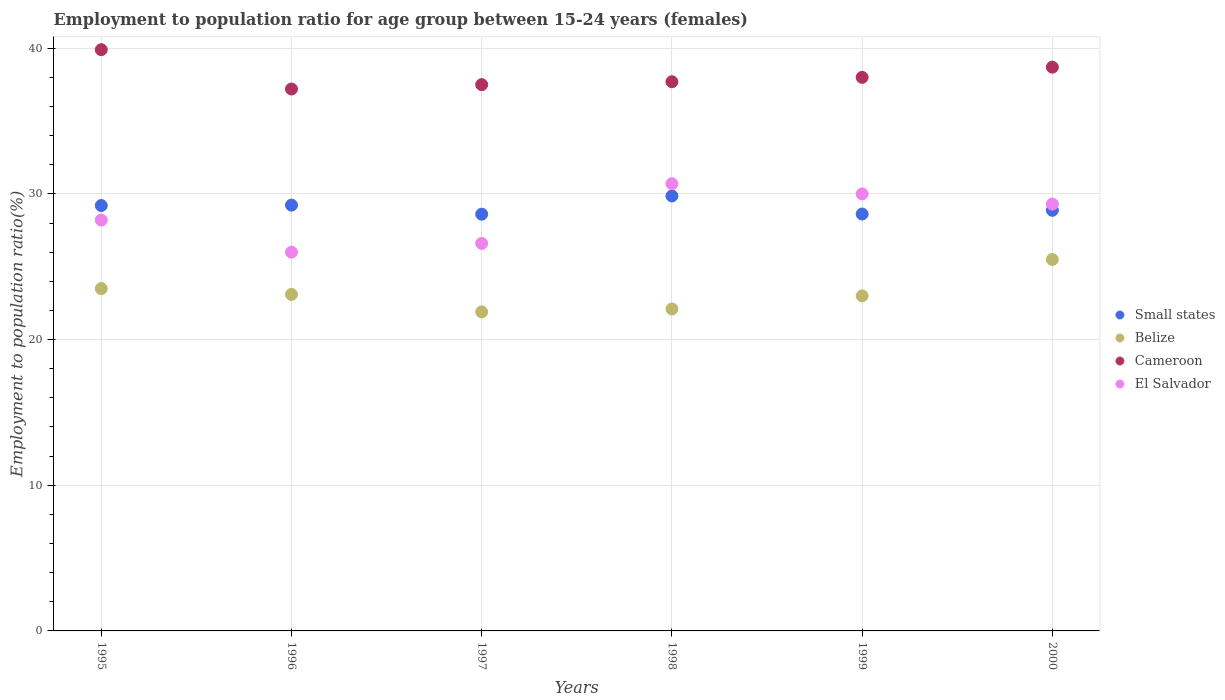Is the number of dotlines equal to the number of legend labels?
Keep it short and to the point. Yes. What is the employment to population ratio in Cameroon in 1997?
Your answer should be very brief. 37.5. Across all years, what is the maximum employment to population ratio in Small states?
Offer a very short reply. 29.86. Across all years, what is the minimum employment to population ratio in Cameroon?
Provide a succinct answer. 37.2. In which year was the employment to population ratio in Cameroon minimum?
Keep it short and to the point. 1996. What is the total employment to population ratio in El Salvador in the graph?
Your response must be concise. 170.8. What is the difference between the employment to population ratio in El Salvador in 1997 and that in 1998?
Your answer should be very brief. -4.1. What is the difference between the employment to population ratio in Cameroon in 1999 and the employment to population ratio in El Salvador in 2000?
Ensure brevity in your answer.  8.7. What is the average employment to population ratio in Cameroon per year?
Keep it short and to the point. 38.17. In the year 1998, what is the difference between the employment to population ratio in Belize and employment to population ratio in Small states?
Offer a very short reply. -7.76. In how many years, is the employment to population ratio in El Salvador greater than 2 %?
Your response must be concise. 6. What is the ratio of the employment to population ratio in Small states in 1998 to that in 1999?
Give a very brief answer. 1.04. What is the difference between the highest and the lowest employment to population ratio in Cameroon?
Ensure brevity in your answer.  2.7. Is it the case that in every year, the sum of the employment to population ratio in Cameroon and employment to population ratio in El Salvador  is greater than the employment to population ratio in Small states?
Offer a very short reply. Yes. Is the employment to population ratio in Cameroon strictly greater than the employment to population ratio in Small states over the years?
Your answer should be compact. Yes. What is the difference between two consecutive major ticks on the Y-axis?
Keep it short and to the point. 10. Does the graph contain any zero values?
Provide a succinct answer. No. Does the graph contain grids?
Offer a terse response. Yes. How many legend labels are there?
Make the answer very short. 4. What is the title of the graph?
Keep it short and to the point. Employment to population ratio for age group between 15-24 years (females). What is the label or title of the X-axis?
Offer a very short reply. Years. What is the label or title of the Y-axis?
Offer a terse response. Employment to population ratio(%). What is the Employment to population ratio(%) in Small states in 1995?
Your answer should be very brief. 29.2. What is the Employment to population ratio(%) in Cameroon in 1995?
Keep it short and to the point. 39.9. What is the Employment to population ratio(%) in El Salvador in 1995?
Ensure brevity in your answer.  28.2. What is the Employment to population ratio(%) in Small states in 1996?
Your answer should be compact. 29.23. What is the Employment to population ratio(%) in Belize in 1996?
Offer a terse response. 23.1. What is the Employment to population ratio(%) of Cameroon in 1996?
Give a very brief answer. 37.2. What is the Employment to population ratio(%) of El Salvador in 1996?
Give a very brief answer. 26. What is the Employment to population ratio(%) in Small states in 1997?
Your answer should be compact. 28.61. What is the Employment to population ratio(%) of Belize in 1997?
Offer a terse response. 21.9. What is the Employment to population ratio(%) of Cameroon in 1997?
Keep it short and to the point. 37.5. What is the Employment to population ratio(%) in El Salvador in 1997?
Your answer should be very brief. 26.6. What is the Employment to population ratio(%) of Small states in 1998?
Provide a succinct answer. 29.86. What is the Employment to population ratio(%) of Belize in 1998?
Offer a very short reply. 22.1. What is the Employment to population ratio(%) in Cameroon in 1998?
Your answer should be very brief. 37.7. What is the Employment to population ratio(%) in El Salvador in 1998?
Your answer should be compact. 30.7. What is the Employment to population ratio(%) of Small states in 1999?
Offer a very short reply. 28.62. What is the Employment to population ratio(%) in Belize in 1999?
Offer a very short reply. 23. What is the Employment to population ratio(%) in Cameroon in 1999?
Give a very brief answer. 38. What is the Employment to population ratio(%) in El Salvador in 1999?
Your answer should be very brief. 30. What is the Employment to population ratio(%) of Small states in 2000?
Keep it short and to the point. 28.87. What is the Employment to population ratio(%) in Cameroon in 2000?
Give a very brief answer. 38.7. What is the Employment to population ratio(%) of El Salvador in 2000?
Give a very brief answer. 29.3. Across all years, what is the maximum Employment to population ratio(%) of Small states?
Your response must be concise. 29.86. Across all years, what is the maximum Employment to population ratio(%) in Cameroon?
Offer a terse response. 39.9. Across all years, what is the maximum Employment to population ratio(%) of El Salvador?
Provide a short and direct response. 30.7. Across all years, what is the minimum Employment to population ratio(%) in Small states?
Your answer should be compact. 28.61. Across all years, what is the minimum Employment to population ratio(%) in Belize?
Ensure brevity in your answer.  21.9. Across all years, what is the minimum Employment to population ratio(%) of Cameroon?
Provide a succinct answer. 37.2. Across all years, what is the minimum Employment to population ratio(%) of El Salvador?
Your response must be concise. 26. What is the total Employment to population ratio(%) in Small states in the graph?
Your answer should be very brief. 174.39. What is the total Employment to population ratio(%) of Belize in the graph?
Ensure brevity in your answer.  139.1. What is the total Employment to population ratio(%) of Cameroon in the graph?
Your answer should be very brief. 229. What is the total Employment to population ratio(%) in El Salvador in the graph?
Give a very brief answer. 170.8. What is the difference between the Employment to population ratio(%) of Small states in 1995 and that in 1996?
Offer a very short reply. -0.03. What is the difference between the Employment to population ratio(%) in Belize in 1995 and that in 1996?
Make the answer very short. 0.4. What is the difference between the Employment to population ratio(%) of Small states in 1995 and that in 1997?
Provide a succinct answer. 0.59. What is the difference between the Employment to population ratio(%) of Belize in 1995 and that in 1997?
Your answer should be very brief. 1.6. What is the difference between the Employment to population ratio(%) of Cameroon in 1995 and that in 1997?
Your response must be concise. 2.4. What is the difference between the Employment to population ratio(%) of Small states in 1995 and that in 1998?
Make the answer very short. -0.66. What is the difference between the Employment to population ratio(%) of Small states in 1995 and that in 1999?
Offer a very short reply. 0.58. What is the difference between the Employment to population ratio(%) of Belize in 1995 and that in 1999?
Offer a terse response. 0.5. What is the difference between the Employment to population ratio(%) of Small states in 1995 and that in 2000?
Your answer should be compact. 0.33. What is the difference between the Employment to population ratio(%) in Belize in 1995 and that in 2000?
Your response must be concise. -2. What is the difference between the Employment to population ratio(%) in Small states in 1996 and that in 1997?
Give a very brief answer. 0.62. What is the difference between the Employment to population ratio(%) in Belize in 1996 and that in 1997?
Offer a very short reply. 1.2. What is the difference between the Employment to population ratio(%) in Cameroon in 1996 and that in 1997?
Offer a very short reply. -0.3. What is the difference between the Employment to population ratio(%) in Small states in 1996 and that in 1998?
Ensure brevity in your answer.  -0.63. What is the difference between the Employment to population ratio(%) in Belize in 1996 and that in 1998?
Make the answer very short. 1. What is the difference between the Employment to population ratio(%) of El Salvador in 1996 and that in 1998?
Your answer should be compact. -4.7. What is the difference between the Employment to population ratio(%) of Small states in 1996 and that in 1999?
Your response must be concise. 0.61. What is the difference between the Employment to population ratio(%) of Belize in 1996 and that in 1999?
Make the answer very short. 0.1. What is the difference between the Employment to population ratio(%) in Cameroon in 1996 and that in 1999?
Your response must be concise. -0.8. What is the difference between the Employment to population ratio(%) in El Salvador in 1996 and that in 1999?
Give a very brief answer. -4. What is the difference between the Employment to population ratio(%) of Small states in 1996 and that in 2000?
Give a very brief answer. 0.36. What is the difference between the Employment to population ratio(%) in Belize in 1996 and that in 2000?
Offer a very short reply. -2.4. What is the difference between the Employment to population ratio(%) of El Salvador in 1996 and that in 2000?
Ensure brevity in your answer.  -3.3. What is the difference between the Employment to population ratio(%) in Small states in 1997 and that in 1998?
Provide a short and direct response. -1.25. What is the difference between the Employment to population ratio(%) of El Salvador in 1997 and that in 1998?
Your response must be concise. -4.1. What is the difference between the Employment to population ratio(%) in Small states in 1997 and that in 1999?
Offer a terse response. -0.01. What is the difference between the Employment to population ratio(%) in Cameroon in 1997 and that in 1999?
Provide a succinct answer. -0.5. What is the difference between the Employment to population ratio(%) of Small states in 1997 and that in 2000?
Keep it short and to the point. -0.27. What is the difference between the Employment to population ratio(%) of Belize in 1997 and that in 2000?
Offer a very short reply. -3.6. What is the difference between the Employment to population ratio(%) of Cameroon in 1997 and that in 2000?
Provide a short and direct response. -1.2. What is the difference between the Employment to population ratio(%) in Small states in 1998 and that in 1999?
Make the answer very short. 1.24. What is the difference between the Employment to population ratio(%) in Belize in 1998 and that in 1999?
Give a very brief answer. -0.9. What is the difference between the Employment to population ratio(%) of Cameroon in 1998 and that in 1999?
Keep it short and to the point. -0.3. What is the difference between the Employment to population ratio(%) of El Salvador in 1998 and that in 1999?
Your answer should be compact. 0.7. What is the difference between the Employment to population ratio(%) of Small states in 1998 and that in 2000?
Your answer should be very brief. 0.98. What is the difference between the Employment to population ratio(%) of Cameroon in 1998 and that in 2000?
Provide a short and direct response. -1. What is the difference between the Employment to population ratio(%) of El Salvador in 1998 and that in 2000?
Your response must be concise. 1.4. What is the difference between the Employment to population ratio(%) of Small states in 1999 and that in 2000?
Provide a succinct answer. -0.26. What is the difference between the Employment to population ratio(%) in Small states in 1995 and the Employment to population ratio(%) in Belize in 1996?
Make the answer very short. 6.1. What is the difference between the Employment to population ratio(%) of Small states in 1995 and the Employment to population ratio(%) of Cameroon in 1996?
Your answer should be compact. -8. What is the difference between the Employment to population ratio(%) in Small states in 1995 and the Employment to population ratio(%) in El Salvador in 1996?
Ensure brevity in your answer.  3.2. What is the difference between the Employment to population ratio(%) in Belize in 1995 and the Employment to population ratio(%) in Cameroon in 1996?
Give a very brief answer. -13.7. What is the difference between the Employment to population ratio(%) in Belize in 1995 and the Employment to population ratio(%) in El Salvador in 1996?
Provide a succinct answer. -2.5. What is the difference between the Employment to population ratio(%) of Cameroon in 1995 and the Employment to population ratio(%) of El Salvador in 1996?
Your response must be concise. 13.9. What is the difference between the Employment to population ratio(%) of Small states in 1995 and the Employment to population ratio(%) of Belize in 1997?
Your answer should be very brief. 7.3. What is the difference between the Employment to population ratio(%) of Small states in 1995 and the Employment to population ratio(%) of Cameroon in 1997?
Provide a short and direct response. -8.3. What is the difference between the Employment to population ratio(%) in Small states in 1995 and the Employment to population ratio(%) in El Salvador in 1997?
Provide a short and direct response. 2.6. What is the difference between the Employment to population ratio(%) in Belize in 1995 and the Employment to population ratio(%) in El Salvador in 1997?
Make the answer very short. -3.1. What is the difference between the Employment to population ratio(%) of Cameroon in 1995 and the Employment to population ratio(%) of El Salvador in 1997?
Your response must be concise. 13.3. What is the difference between the Employment to population ratio(%) of Small states in 1995 and the Employment to population ratio(%) of Belize in 1998?
Your answer should be compact. 7.1. What is the difference between the Employment to population ratio(%) of Small states in 1995 and the Employment to population ratio(%) of Cameroon in 1998?
Give a very brief answer. -8.5. What is the difference between the Employment to population ratio(%) in Small states in 1995 and the Employment to population ratio(%) in El Salvador in 1998?
Give a very brief answer. -1.5. What is the difference between the Employment to population ratio(%) of Cameroon in 1995 and the Employment to population ratio(%) of El Salvador in 1998?
Make the answer very short. 9.2. What is the difference between the Employment to population ratio(%) in Small states in 1995 and the Employment to population ratio(%) in Belize in 1999?
Make the answer very short. 6.2. What is the difference between the Employment to population ratio(%) of Small states in 1995 and the Employment to population ratio(%) of Cameroon in 1999?
Provide a short and direct response. -8.8. What is the difference between the Employment to population ratio(%) in Small states in 1995 and the Employment to population ratio(%) in El Salvador in 1999?
Ensure brevity in your answer.  -0.8. What is the difference between the Employment to population ratio(%) in Belize in 1995 and the Employment to population ratio(%) in El Salvador in 1999?
Make the answer very short. -6.5. What is the difference between the Employment to population ratio(%) of Cameroon in 1995 and the Employment to population ratio(%) of El Salvador in 1999?
Provide a short and direct response. 9.9. What is the difference between the Employment to population ratio(%) of Small states in 1995 and the Employment to population ratio(%) of Belize in 2000?
Make the answer very short. 3.7. What is the difference between the Employment to population ratio(%) in Small states in 1995 and the Employment to population ratio(%) in Cameroon in 2000?
Provide a short and direct response. -9.5. What is the difference between the Employment to population ratio(%) of Small states in 1995 and the Employment to population ratio(%) of El Salvador in 2000?
Provide a succinct answer. -0.1. What is the difference between the Employment to population ratio(%) of Belize in 1995 and the Employment to population ratio(%) of Cameroon in 2000?
Ensure brevity in your answer.  -15.2. What is the difference between the Employment to population ratio(%) of Cameroon in 1995 and the Employment to population ratio(%) of El Salvador in 2000?
Make the answer very short. 10.6. What is the difference between the Employment to population ratio(%) in Small states in 1996 and the Employment to population ratio(%) in Belize in 1997?
Your answer should be very brief. 7.33. What is the difference between the Employment to population ratio(%) of Small states in 1996 and the Employment to population ratio(%) of Cameroon in 1997?
Make the answer very short. -8.27. What is the difference between the Employment to population ratio(%) in Small states in 1996 and the Employment to population ratio(%) in El Salvador in 1997?
Make the answer very short. 2.63. What is the difference between the Employment to population ratio(%) of Belize in 1996 and the Employment to population ratio(%) of Cameroon in 1997?
Your answer should be compact. -14.4. What is the difference between the Employment to population ratio(%) of Small states in 1996 and the Employment to population ratio(%) of Belize in 1998?
Provide a succinct answer. 7.13. What is the difference between the Employment to population ratio(%) of Small states in 1996 and the Employment to population ratio(%) of Cameroon in 1998?
Give a very brief answer. -8.47. What is the difference between the Employment to population ratio(%) of Small states in 1996 and the Employment to population ratio(%) of El Salvador in 1998?
Offer a very short reply. -1.47. What is the difference between the Employment to population ratio(%) in Belize in 1996 and the Employment to population ratio(%) in Cameroon in 1998?
Keep it short and to the point. -14.6. What is the difference between the Employment to population ratio(%) in Belize in 1996 and the Employment to population ratio(%) in El Salvador in 1998?
Offer a terse response. -7.6. What is the difference between the Employment to population ratio(%) of Cameroon in 1996 and the Employment to population ratio(%) of El Salvador in 1998?
Provide a succinct answer. 6.5. What is the difference between the Employment to population ratio(%) in Small states in 1996 and the Employment to population ratio(%) in Belize in 1999?
Your answer should be compact. 6.23. What is the difference between the Employment to population ratio(%) in Small states in 1996 and the Employment to population ratio(%) in Cameroon in 1999?
Offer a terse response. -8.77. What is the difference between the Employment to population ratio(%) of Small states in 1996 and the Employment to population ratio(%) of El Salvador in 1999?
Offer a terse response. -0.77. What is the difference between the Employment to population ratio(%) of Belize in 1996 and the Employment to population ratio(%) of Cameroon in 1999?
Your response must be concise. -14.9. What is the difference between the Employment to population ratio(%) of Cameroon in 1996 and the Employment to population ratio(%) of El Salvador in 1999?
Offer a terse response. 7.2. What is the difference between the Employment to population ratio(%) of Small states in 1996 and the Employment to population ratio(%) of Belize in 2000?
Give a very brief answer. 3.73. What is the difference between the Employment to population ratio(%) in Small states in 1996 and the Employment to population ratio(%) in Cameroon in 2000?
Provide a succinct answer. -9.47. What is the difference between the Employment to population ratio(%) in Small states in 1996 and the Employment to population ratio(%) in El Salvador in 2000?
Your answer should be compact. -0.07. What is the difference between the Employment to population ratio(%) in Belize in 1996 and the Employment to population ratio(%) in Cameroon in 2000?
Provide a short and direct response. -15.6. What is the difference between the Employment to population ratio(%) of Belize in 1996 and the Employment to population ratio(%) of El Salvador in 2000?
Provide a succinct answer. -6.2. What is the difference between the Employment to population ratio(%) in Small states in 1997 and the Employment to population ratio(%) in Belize in 1998?
Provide a succinct answer. 6.51. What is the difference between the Employment to population ratio(%) in Small states in 1997 and the Employment to population ratio(%) in Cameroon in 1998?
Your answer should be compact. -9.09. What is the difference between the Employment to population ratio(%) of Small states in 1997 and the Employment to population ratio(%) of El Salvador in 1998?
Your answer should be compact. -2.09. What is the difference between the Employment to population ratio(%) of Belize in 1997 and the Employment to population ratio(%) of Cameroon in 1998?
Provide a short and direct response. -15.8. What is the difference between the Employment to population ratio(%) of Belize in 1997 and the Employment to population ratio(%) of El Salvador in 1998?
Offer a very short reply. -8.8. What is the difference between the Employment to population ratio(%) in Cameroon in 1997 and the Employment to population ratio(%) in El Salvador in 1998?
Keep it short and to the point. 6.8. What is the difference between the Employment to population ratio(%) in Small states in 1997 and the Employment to population ratio(%) in Belize in 1999?
Offer a terse response. 5.61. What is the difference between the Employment to population ratio(%) in Small states in 1997 and the Employment to population ratio(%) in Cameroon in 1999?
Offer a very short reply. -9.39. What is the difference between the Employment to population ratio(%) in Small states in 1997 and the Employment to population ratio(%) in El Salvador in 1999?
Make the answer very short. -1.39. What is the difference between the Employment to population ratio(%) of Belize in 1997 and the Employment to population ratio(%) of Cameroon in 1999?
Offer a terse response. -16.1. What is the difference between the Employment to population ratio(%) of Belize in 1997 and the Employment to population ratio(%) of El Salvador in 1999?
Give a very brief answer. -8.1. What is the difference between the Employment to population ratio(%) of Cameroon in 1997 and the Employment to population ratio(%) of El Salvador in 1999?
Your answer should be very brief. 7.5. What is the difference between the Employment to population ratio(%) in Small states in 1997 and the Employment to population ratio(%) in Belize in 2000?
Offer a very short reply. 3.11. What is the difference between the Employment to population ratio(%) in Small states in 1997 and the Employment to population ratio(%) in Cameroon in 2000?
Your answer should be very brief. -10.09. What is the difference between the Employment to population ratio(%) of Small states in 1997 and the Employment to population ratio(%) of El Salvador in 2000?
Your answer should be compact. -0.69. What is the difference between the Employment to population ratio(%) of Belize in 1997 and the Employment to population ratio(%) of Cameroon in 2000?
Provide a succinct answer. -16.8. What is the difference between the Employment to population ratio(%) in Cameroon in 1997 and the Employment to population ratio(%) in El Salvador in 2000?
Your answer should be compact. 8.2. What is the difference between the Employment to population ratio(%) in Small states in 1998 and the Employment to population ratio(%) in Belize in 1999?
Provide a succinct answer. 6.86. What is the difference between the Employment to population ratio(%) in Small states in 1998 and the Employment to population ratio(%) in Cameroon in 1999?
Your response must be concise. -8.14. What is the difference between the Employment to population ratio(%) in Small states in 1998 and the Employment to population ratio(%) in El Salvador in 1999?
Provide a succinct answer. -0.14. What is the difference between the Employment to population ratio(%) in Belize in 1998 and the Employment to population ratio(%) in Cameroon in 1999?
Provide a short and direct response. -15.9. What is the difference between the Employment to population ratio(%) in Belize in 1998 and the Employment to population ratio(%) in El Salvador in 1999?
Ensure brevity in your answer.  -7.9. What is the difference between the Employment to population ratio(%) in Small states in 1998 and the Employment to population ratio(%) in Belize in 2000?
Make the answer very short. 4.36. What is the difference between the Employment to population ratio(%) of Small states in 1998 and the Employment to population ratio(%) of Cameroon in 2000?
Your answer should be very brief. -8.84. What is the difference between the Employment to population ratio(%) in Small states in 1998 and the Employment to population ratio(%) in El Salvador in 2000?
Offer a very short reply. 0.56. What is the difference between the Employment to population ratio(%) in Belize in 1998 and the Employment to population ratio(%) in Cameroon in 2000?
Give a very brief answer. -16.6. What is the difference between the Employment to population ratio(%) in Small states in 1999 and the Employment to population ratio(%) in Belize in 2000?
Provide a succinct answer. 3.12. What is the difference between the Employment to population ratio(%) in Small states in 1999 and the Employment to population ratio(%) in Cameroon in 2000?
Give a very brief answer. -10.08. What is the difference between the Employment to population ratio(%) of Small states in 1999 and the Employment to population ratio(%) of El Salvador in 2000?
Ensure brevity in your answer.  -0.68. What is the difference between the Employment to population ratio(%) of Belize in 1999 and the Employment to population ratio(%) of Cameroon in 2000?
Offer a terse response. -15.7. What is the average Employment to population ratio(%) in Small states per year?
Provide a short and direct response. 29.07. What is the average Employment to population ratio(%) of Belize per year?
Your answer should be very brief. 23.18. What is the average Employment to population ratio(%) of Cameroon per year?
Provide a short and direct response. 38.17. What is the average Employment to population ratio(%) of El Salvador per year?
Offer a very short reply. 28.47. In the year 1995, what is the difference between the Employment to population ratio(%) of Small states and Employment to population ratio(%) of Belize?
Ensure brevity in your answer.  5.7. In the year 1995, what is the difference between the Employment to population ratio(%) in Small states and Employment to population ratio(%) in Cameroon?
Your answer should be compact. -10.7. In the year 1995, what is the difference between the Employment to population ratio(%) in Small states and Employment to population ratio(%) in El Salvador?
Your answer should be very brief. 1. In the year 1995, what is the difference between the Employment to population ratio(%) of Belize and Employment to population ratio(%) of Cameroon?
Provide a succinct answer. -16.4. In the year 1995, what is the difference between the Employment to population ratio(%) in Cameroon and Employment to population ratio(%) in El Salvador?
Your answer should be compact. 11.7. In the year 1996, what is the difference between the Employment to population ratio(%) in Small states and Employment to population ratio(%) in Belize?
Keep it short and to the point. 6.13. In the year 1996, what is the difference between the Employment to population ratio(%) of Small states and Employment to population ratio(%) of Cameroon?
Make the answer very short. -7.97. In the year 1996, what is the difference between the Employment to population ratio(%) in Small states and Employment to population ratio(%) in El Salvador?
Make the answer very short. 3.23. In the year 1996, what is the difference between the Employment to population ratio(%) in Belize and Employment to population ratio(%) in Cameroon?
Provide a short and direct response. -14.1. In the year 1997, what is the difference between the Employment to population ratio(%) in Small states and Employment to population ratio(%) in Belize?
Your answer should be very brief. 6.71. In the year 1997, what is the difference between the Employment to population ratio(%) of Small states and Employment to population ratio(%) of Cameroon?
Offer a terse response. -8.89. In the year 1997, what is the difference between the Employment to population ratio(%) of Small states and Employment to population ratio(%) of El Salvador?
Provide a succinct answer. 2.01. In the year 1997, what is the difference between the Employment to population ratio(%) in Belize and Employment to population ratio(%) in Cameroon?
Ensure brevity in your answer.  -15.6. In the year 1997, what is the difference between the Employment to population ratio(%) in Cameroon and Employment to population ratio(%) in El Salvador?
Keep it short and to the point. 10.9. In the year 1998, what is the difference between the Employment to population ratio(%) of Small states and Employment to population ratio(%) of Belize?
Give a very brief answer. 7.76. In the year 1998, what is the difference between the Employment to population ratio(%) of Small states and Employment to population ratio(%) of Cameroon?
Give a very brief answer. -7.84. In the year 1998, what is the difference between the Employment to population ratio(%) of Small states and Employment to population ratio(%) of El Salvador?
Provide a succinct answer. -0.84. In the year 1998, what is the difference between the Employment to population ratio(%) of Belize and Employment to population ratio(%) of Cameroon?
Give a very brief answer. -15.6. In the year 1998, what is the difference between the Employment to population ratio(%) of Cameroon and Employment to population ratio(%) of El Salvador?
Keep it short and to the point. 7. In the year 1999, what is the difference between the Employment to population ratio(%) of Small states and Employment to population ratio(%) of Belize?
Your answer should be very brief. 5.62. In the year 1999, what is the difference between the Employment to population ratio(%) of Small states and Employment to population ratio(%) of Cameroon?
Ensure brevity in your answer.  -9.38. In the year 1999, what is the difference between the Employment to population ratio(%) of Small states and Employment to population ratio(%) of El Salvador?
Your response must be concise. -1.38. In the year 1999, what is the difference between the Employment to population ratio(%) of Belize and Employment to population ratio(%) of Cameroon?
Give a very brief answer. -15. In the year 2000, what is the difference between the Employment to population ratio(%) of Small states and Employment to population ratio(%) of Belize?
Offer a very short reply. 3.37. In the year 2000, what is the difference between the Employment to population ratio(%) in Small states and Employment to population ratio(%) in Cameroon?
Provide a short and direct response. -9.83. In the year 2000, what is the difference between the Employment to population ratio(%) of Small states and Employment to population ratio(%) of El Salvador?
Provide a succinct answer. -0.43. In the year 2000, what is the difference between the Employment to population ratio(%) in Belize and Employment to population ratio(%) in El Salvador?
Provide a succinct answer. -3.8. What is the ratio of the Employment to population ratio(%) of Small states in 1995 to that in 1996?
Your answer should be compact. 1. What is the ratio of the Employment to population ratio(%) in Belize in 1995 to that in 1996?
Offer a terse response. 1.02. What is the ratio of the Employment to population ratio(%) of Cameroon in 1995 to that in 1996?
Provide a succinct answer. 1.07. What is the ratio of the Employment to population ratio(%) in El Salvador in 1995 to that in 1996?
Your response must be concise. 1.08. What is the ratio of the Employment to population ratio(%) of Small states in 1995 to that in 1997?
Make the answer very short. 1.02. What is the ratio of the Employment to population ratio(%) in Belize in 1995 to that in 1997?
Ensure brevity in your answer.  1.07. What is the ratio of the Employment to population ratio(%) in Cameroon in 1995 to that in 1997?
Keep it short and to the point. 1.06. What is the ratio of the Employment to population ratio(%) in El Salvador in 1995 to that in 1997?
Provide a short and direct response. 1.06. What is the ratio of the Employment to population ratio(%) of Belize in 1995 to that in 1998?
Your answer should be compact. 1.06. What is the ratio of the Employment to population ratio(%) in Cameroon in 1995 to that in 1998?
Your answer should be compact. 1.06. What is the ratio of the Employment to population ratio(%) of El Salvador in 1995 to that in 1998?
Your answer should be very brief. 0.92. What is the ratio of the Employment to population ratio(%) of Small states in 1995 to that in 1999?
Ensure brevity in your answer.  1.02. What is the ratio of the Employment to population ratio(%) in Belize in 1995 to that in 1999?
Ensure brevity in your answer.  1.02. What is the ratio of the Employment to population ratio(%) of Cameroon in 1995 to that in 1999?
Your answer should be very brief. 1.05. What is the ratio of the Employment to population ratio(%) of El Salvador in 1995 to that in 1999?
Your response must be concise. 0.94. What is the ratio of the Employment to population ratio(%) of Small states in 1995 to that in 2000?
Provide a succinct answer. 1.01. What is the ratio of the Employment to population ratio(%) of Belize in 1995 to that in 2000?
Give a very brief answer. 0.92. What is the ratio of the Employment to population ratio(%) in Cameroon in 1995 to that in 2000?
Your answer should be compact. 1.03. What is the ratio of the Employment to population ratio(%) of El Salvador in 1995 to that in 2000?
Make the answer very short. 0.96. What is the ratio of the Employment to population ratio(%) in Small states in 1996 to that in 1997?
Provide a succinct answer. 1.02. What is the ratio of the Employment to population ratio(%) of Belize in 1996 to that in 1997?
Offer a very short reply. 1.05. What is the ratio of the Employment to population ratio(%) in Cameroon in 1996 to that in 1997?
Your answer should be compact. 0.99. What is the ratio of the Employment to population ratio(%) in El Salvador in 1996 to that in 1997?
Your answer should be compact. 0.98. What is the ratio of the Employment to population ratio(%) in Small states in 1996 to that in 1998?
Your answer should be very brief. 0.98. What is the ratio of the Employment to population ratio(%) in Belize in 1996 to that in 1998?
Provide a succinct answer. 1.05. What is the ratio of the Employment to population ratio(%) in Cameroon in 1996 to that in 1998?
Your answer should be very brief. 0.99. What is the ratio of the Employment to population ratio(%) in El Salvador in 1996 to that in 1998?
Make the answer very short. 0.85. What is the ratio of the Employment to population ratio(%) of Small states in 1996 to that in 1999?
Offer a terse response. 1.02. What is the ratio of the Employment to population ratio(%) in Cameroon in 1996 to that in 1999?
Ensure brevity in your answer.  0.98. What is the ratio of the Employment to population ratio(%) of El Salvador in 1996 to that in 1999?
Your response must be concise. 0.87. What is the ratio of the Employment to population ratio(%) in Small states in 1996 to that in 2000?
Ensure brevity in your answer.  1.01. What is the ratio of the Employment to population ratio(%) in Belize in 1996 to that in 2000?
Your answer should be compact. 0.91. What is the ratio of the Employment to population ratio(%) of Cameroon in 1996 to that in 2000?
Your answer should be very brief. 0.96. What is the ratio of the Employment to population ratio(%) of El Salvador in 1996 to that in 2000?
Keep it short and to the point. 0.89. What is the ratio of the Employment to population ratio(%) in Small states in 1997 to that in 1998?
Keep it short and to the point. 0.96. What is the ratio of the Employment to population ratio(%) of Cameroon in 1997 to that in 1998?
Your answer should be very brief. 0.99. What is the ratio of the Employment to population ratio(%) in El Salvador in 1997 to that in 1998?
Your answer should be very brief. 0.87. What is the ratio of the Employment to population ratio(%) in Small states in 1997 to that in 1999?
Your response must be concise. 1. What is the ratio of the Employment to population ratio(%) of Belize in 1997 to that in 1999?
Your answer should be very brief. 0.95. What is the ratio of the Employment to population ratio(%) of El Salvador in 1997 to that in 1999?
Offer a terse response. 0.89. What is the ratio of the Employment to population ratio(%) of Belize in 1997 to that in 2000?
Give a very brief answer. 0.86. What is the ratio of the Employment to population ratio(%) of Cameroon in 1997 to that in 2000?
Provide a short and direct response. 0.97. What is the ratio of the Employment to population ratio(%) of El Salvador in 1997 to that in 2000?
Ensure brevity in your answer.  0.91. What is the ratio of the Employment to population ratio(%) in Small states in 1998 to that in 1999?
Provide a short and direct response. 1.04. What is the ratio of the Employment to population ratio(%) of Belize in 1998 to that in 1999?
Offer a very short reply. 0.96. What is the ratio of the Employment to population ratio(%) in El Salvador in 1998 to that in 1999?
Your response must be concise. 1.02. What is the ratio of the Employment to population ratio(%) in Small states in 1998 to that in 2000?
Ensure brevity in your answer.  1.03. What is the ratio of the Employment to population ratio(%) of Belize in 1998 to that in 2000?
Ensure brevity in your answer.  0.87. What is the ratio of the Employment to population ratio(%) in Cameroon in 1998 to that in 2000?
Give a very brief answer. 0.97. What is the ratio of the Employment to population ratio(%) of El Salvador in 1998 to that in 2000?
Provide a succinct answer. 1.05. What is the ratio of the Employment to population ratio(%) in Belize in 1999 to that in 2000?
Provide a short and direct response. 0.9. What is the ratio of the Employment to population ratio(%) of Cameroon in 1999 to that in 2000?
Make the answer very short. 0.98. What is the ratio of the Employment to population ratio(%) of El Salvador in 1999 to that in 2000?
Ensure brevity in your answer.  1.02. What is the difference between the highest and the second highest Employment to population ratio(%) in Small states?
Your response must be concise. 0.63. What is the difference between the highest and the second highest Employment to population ratio(%) in Belize?
Ensure brevity in your answer.  2. What is the difference between the highest and the second highest Employment to population ratio(%) in Cameroon?
Provide a short and direct response. 1.2. What is the difference between the highest and the lowest Employment to population ratio(%) of Small states?
Offer a very short reply. 1.25. What is the difference between the highest and the lowest Employment to population ratio(%) in Belize?
Provide a short and direct response. 3.6. What is the difference between the highest and the lowest Employment to population ratio(%) of Cameroon?
Provide a succinct answer. 2.7. 